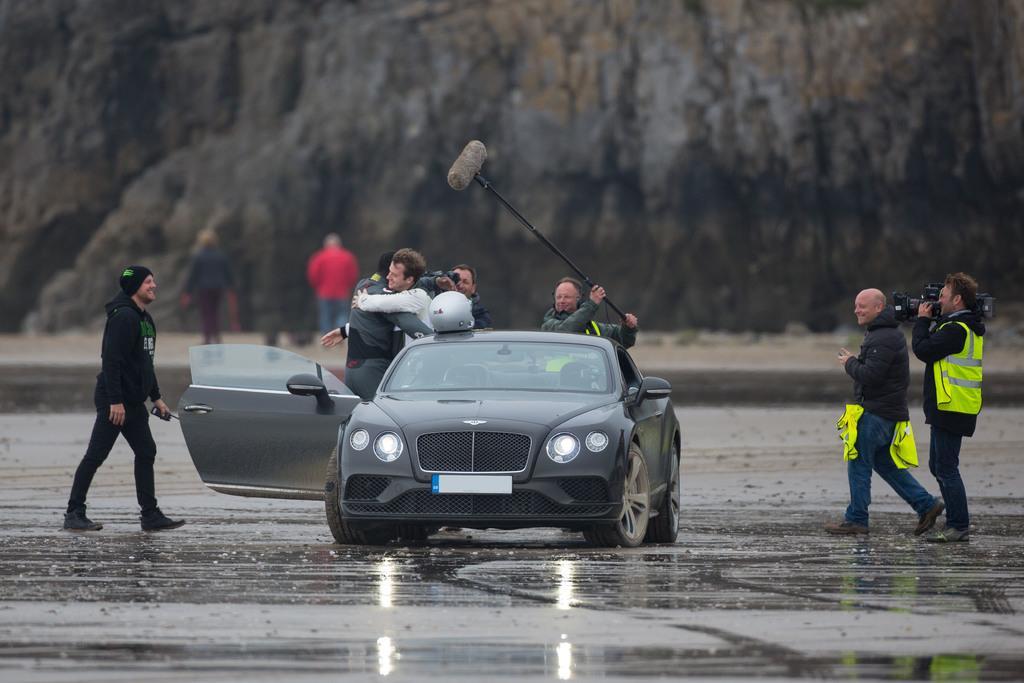How would you summarize this image in a sentence or two? This is a picture taken in the outdoor, there are people behind the car. The man is holding the camera and recording the persons on the top of the car there is helmet and the back ground of the car is a mountain. 